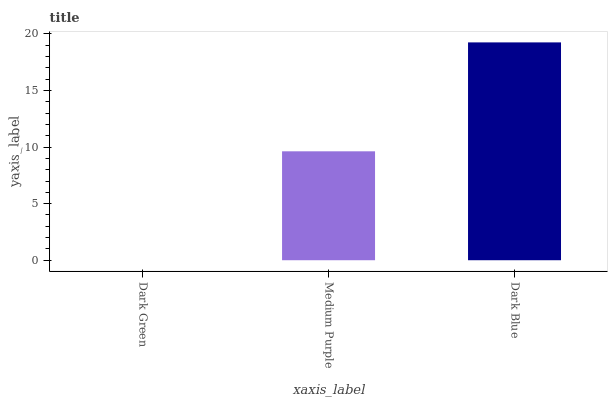Is Dark Green the minimum?
Answer yes or no. Yes. Is Dark Blue the maximum?
Answer yes or no. Yes. Is Medium Purple the minimum?
Answer yes or no. No. Is Medium Purple the maximum?
Answer yes or no. No. Is Medium Purple greater than Dark Green?
Answer yes or no. Yes. Is Dark Green less than Medium Purple?
Answer yes or no. Yes. Is Dark Green greater than Medium Purple?
Answer yes or no. No. Is Medium Purple less than Dark Green?
Answer yes or no. No. Is Medium Purple the high median?
Answer yes or no. Yes. Is Medium Purple the low median?
Answer yes or no. Yes. Is Dark Blue the high median?
Answer yes or no. No. Is Dark Green the low median?
Answer yes or no. No. 